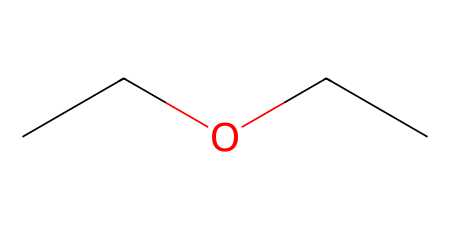What is the molecular formula of diethyl ether? The SMILES representation "CCOCC" indicates there are two ethyl groups (C2H5) connected by an oxygen atom (O). This can be combined to determine the molecular formula: C4H10O.
Answer: C4H10O How many carbon atoms are in diethyl ether? From the SMILES representation "CCOCC", we can identify that there are four carbon atoms (the two ethyl groups contribute two carbons each).
Answer: 4 What type of functional group does diethyl ether contain? The presence of an oxygen atom between two alkyl groups (in this case, two ethyl groups) indicates the functional group is an ether.
Answer: ether What is the total number of hydrogen atoms in diethyl ether? In the SMILES representation "CCOCC", each ethyl group (C2H5) contributes five hydrogen atoms, resulting in a total of ten hydrogen atoms when adding them together (5 + 5 = 10).
Answer: 10 What is the connectivity type of atoms in diethyl ether? The connection pattern shows that two ethyl groups are bonded to a single oxygen atom, establishing the ether connectivity characterized by R-O-R, where R represents the alkyl group.
Answer: R-O-R What molecular property allows diethyl ether to act as an anesthetic? The presence of the ether functional group (R-O-R) contributes to the volatility and low boiling point, properties which are essential for its use as an anesthetic.
Answer: volatility What is the boiling point of diethyl ether? Diethyl ether has a boiling point of approximately 34.6 degrees Celsius, which is attributed to its low molecular weight and ether functional group.
Answer: 34.6 degrees Celsius 